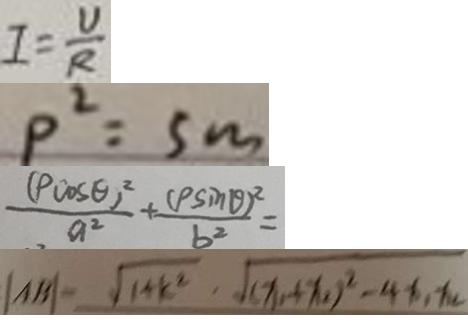<formula> <loc_0><loc_0><loc_500><loc_500>I = \frac { U } { R } 
 p ^ { 2 } = 5 m 
 \frac { ( P \cos \theta ) ^ { 2 } } { a ^ { 2 } } + \frac { ( P \sin \theta ) ^ { 2 } } { b ^ { 2 } } = 
 \vert A B \vert = \sqrt { 1 + k ^ { 2 } } , \sqrt { ( x _ { 1 } + x _ { 2 } ) ^ { 2 } - 4 x _ { 1 } x _ { 2 } }</formula> 